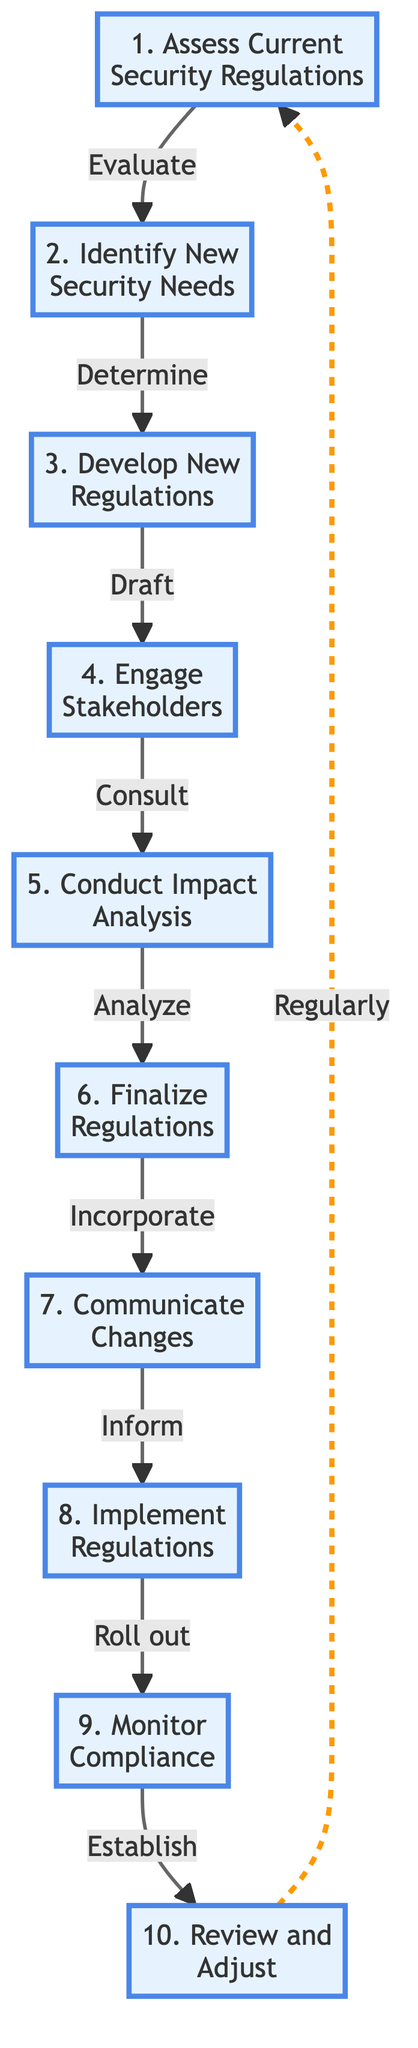What is the first step in the flowchart? The flowchart starts with "Assess Current Security Regulations," which is the first node.
Answer: Assess Current Security Regulations How many steps are there in total? The flowchart contains ten steps, as indicated by the ten nodes labeled from one to ten.
Answer: 10 Which step comes after "Engage Stakeholders"? According to the flowchart, "Conduct Impact Analysis" follows "Engage Stakeholders" in the sequence of steps.
Answer: Conduct Impact Analysis What action is taken after finalizing the regulations? After "Finalize Regulations," the next action is to "Communicate Changes" to all stakeholders involved.
Answer: Communicate Changes Which step involves consulting with external parties? The step "Engage Stakeholders" explicitly mentions consulting with local businesses, law enforcement, and community leaders.
Answer: Engage Stakeholders What happens after "Monitor Compliance"? After "Monitor Compliance," the flow returns to the beginning step to "Review and Adjust" the regulations periodically.
Answer: Review and Adjust How do proposed regulations affect the businesses? The step "Conduct Impact Analysis" is dedicated to analyzing the potential effects of proposed regulations on local businesses and the community.
Answer: Conduct Impact Analysis What is the last step in the flowchart? The last step of the flowchart is "Review and Adjust," which indicates the continual process of improving regulations.
Answer: Review and Adjust What is the primary action of the third step? The primary action of the third step is to "Draft" comprehensive security regulations that will be developed based on previous evaluations.
Answer: Draft 